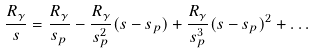Convert formula to latex. <formula><loc_0><loc_0><loc_500><loc_500>\frac { R _ { \gamma } } { s } = \frac { R _ { \gamma } } { s _ { p } } - \frac { R _ { \gamma } } { s _ { p } ^ { 2 } } ( s - s _ { p } ) + \frac { R _ { \gamma } } { s _ { p } ^ { 3 } } ( s - s _ { p } ) ^ { 2 } + \dots</formula> 